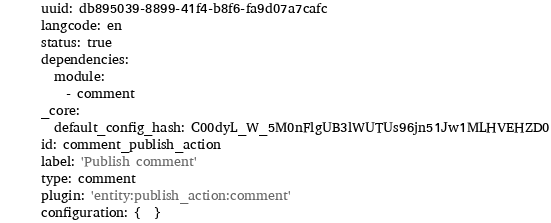Convert code to text. <code><loc_0><loc_0><loc_500><loc_500><_YAML_>uuid: db895039-8899-41f4-b8f6-fa9d07a7cafc
langcode: en
status: true
dependencies:
  module:
    - comment
_core:
  default_config_hash: C00dyL_W_5M0nFlgUB3lWUTUs96jn51Jw1MLHVEHZD0
id: comment_publish_action
label: 'Publish comment'
type: comment
plugin: 'entity:publish_action:comment'
configuration: {  }
</code> 